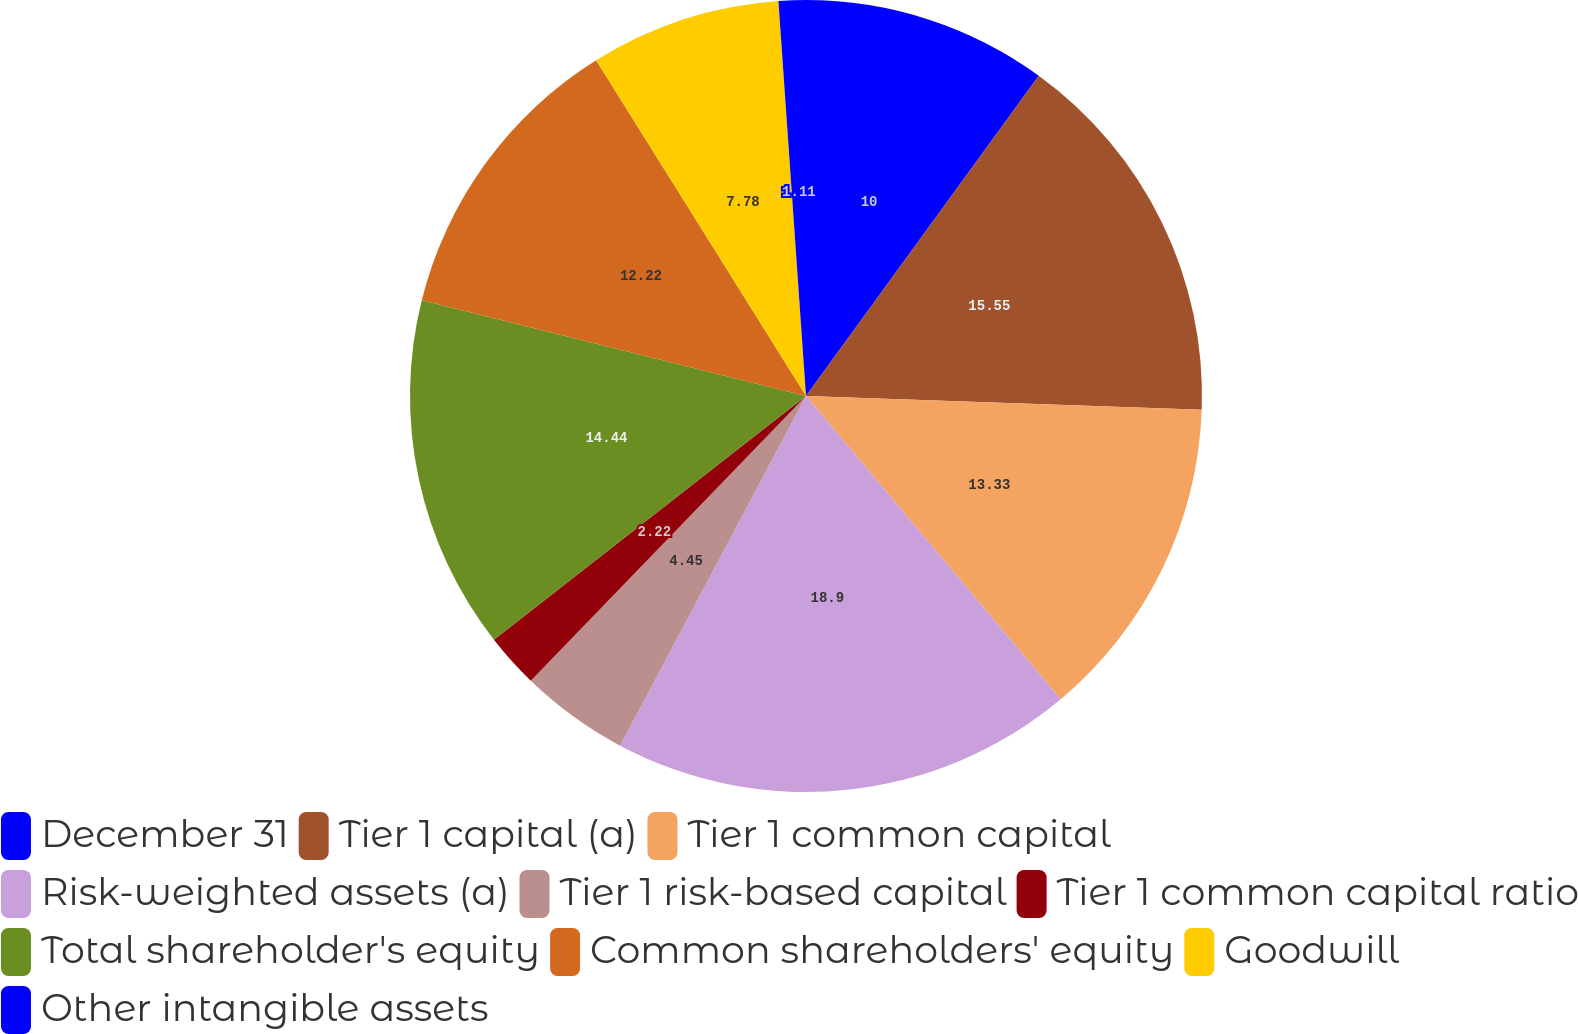Convert chart. <chart><loc_0><loc_0><loc_500><loc_500><pie_chart><fcel>December 31<fcel>Tier 1 capital (a)<fcel>Tier 1 common capital<fcel>Risk-weighted assets (a)<fcel>Tier 1 risk-based capital<fcel>Tier 1 common capital ratio<fcel>Total shareholder's equity<fcel>Common shareholders' equity<fcel>Goodwill<fcel>Other intangible assets<nl><fcel>10.0%<fcel>15.55%<fcel>13.33%<fcel>18.89%<fcel>4.45%<fcel>2.22%<fcel>14.44%<fcel>12.22%<fcel>7.78%<fcel>1.11%<nl></chart> 